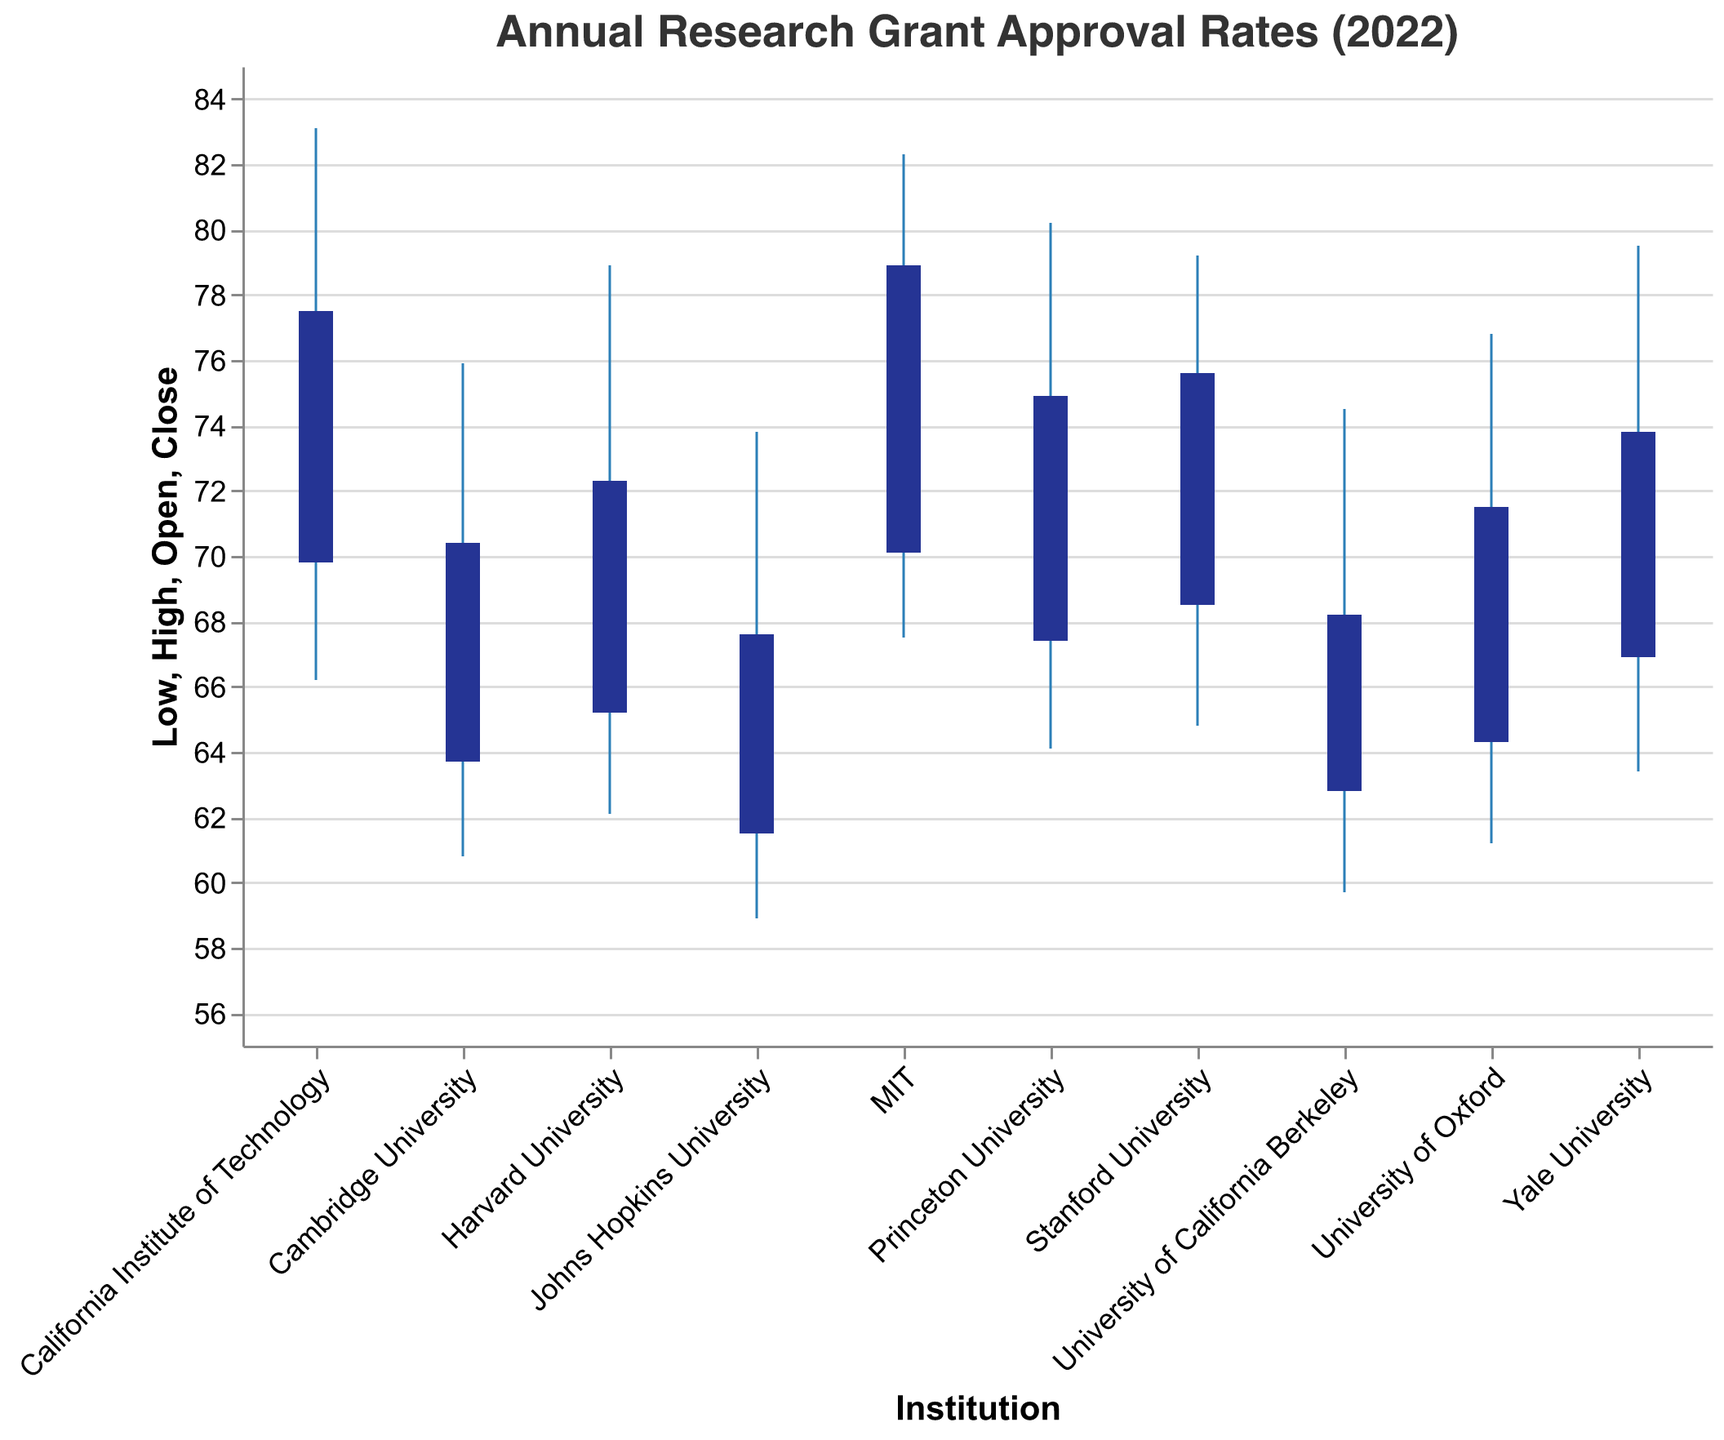What is the highest grant approval rate for Harvard University in 2022? Locate Harvard University on the x-axis and check the "High" value on the chart, which represents the highest approval rate.
Answer: 78.9 What is the range of the grant approval rates for MIT in 2022? Locate MIT on the x-axis and identify the "High" and "Low" values. Subtract the "Low" value from the "High" value to get the range. The High value is 82.3 and the Low value is 67.5; 82.3 - 67.5 gives the range.
Answer: 14.8 Which institution has the lowest "Low" value and what is it? Compare the "Low" values for all institutions. Johns Hopkins University has the lowest "Low" value, which is at the minimum position on the y-axis.
Answer: 58.9 Which institution opened with the highest approval rate in 2022? Compare the "Open" values for all institutions. The highest opening value can be observed at California Institute of Technology with an "Open" value of 69.8.
Answer: California Institute of Technology Compare the grant approval rates at the close of the year between Stanford University and Princeton University. Which institution had a higher closing rate in 2022 and by how much? Locate Stanford University and Princeton University on the x-axis. Identify their "Close" values from the figure. Stanford University has a "Close" rate of 75.6 and Princeton University has a "Close" rate of 74.9. The difference is calculated as 75.6 - 74.9.
Answer: Stanford University by 0.7 What is the median value of the "Close" rates for all institutions in 2022? List out all "Close" values: [67.6, 68.2, 70.4, 71.5, 72.3, 73.8, 74.9, 75.6, 77.5, 78.9]. To find the median, order these values and find the middle value. For an even number of data points, average the two central numbers (73.8 and 74.9), (73.8 + 74.9) / 2.
Answer: 74.35 Is there any institution that did not have their lowest approval rate below 60 in 2022? Look for institutions where the “Low” value on the y-axis is at least 60. Institutions fitting this criterion are MIT, California Institute of Technology, Princeton University, Harvard University, Stanford University, University of Oxford, Cambridge University, and Yale University.
Answer: Yes Which institution had a higher volatility represented by a larger range (difference between High and Low) in the approval rates: University of Oxford or Stanford University? Locate the University of Oxford and Stanford University on the x-axis. Calculate the range for both by subtracting the "Low" value from the "High" value. Oxford has (76.8 - 61.2 = 15.6); Stanford has (79.2 - 64.8 = 14.4).
Answer: University of Oxford What was the closing approval rate for Yale University in 2022? Identify Yale University on the x-axis and find the "Close" value on the chart. This value represents the approval rate at the close of the year.
Answer: 73.8 